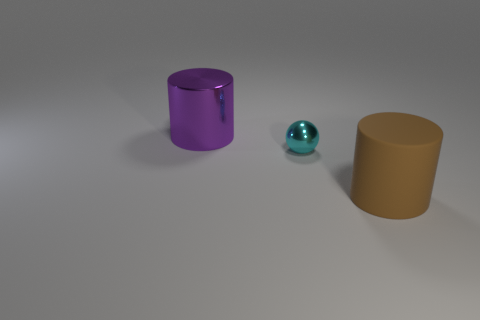What number of other things are there of the same color as the tiny shiny thing?
Your answer should be very brief. 0. There is a metallic thing that is in front of the shiny thing to the left of the ball; what is its color?
Your answer should be compact. Cyan. What shape is the cyan shiny object?
Provide a succinct answer. Sphere. There is a cylinder that is left of the cyan metal thing; does it have the same size as the cyan thing?
Keep it short and to the point. No. Are there any yellow objects that have the same material as the big brown thing?
Offer a terse response. No. How many objects are objects that are behind the large brown matte cylinder or things?
Give a very brief answer. 3. Are any purple objects visible?
Offer a terse response. Yes. There is a cylinder that is right of the cyan metal sphere; what is its size?
Ensure brevity in your answer.  Large. Do the metal object in front of the big purple metallic cylinder and the matte object have the same color?
Offer a terse response. No. How many big green metallic things have the same shape as the big rubber thing?
Make the answer very short. 0. 